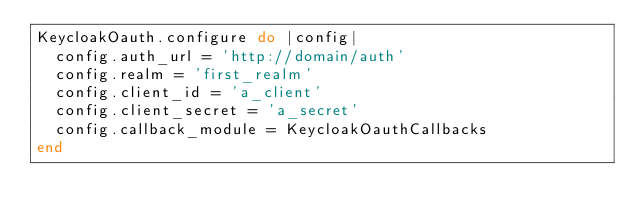<code> <loc_0><loc_0><loc_500><loc_500><_Ruby_>KeycloakOauth.configure do |config|
  config.auth_url = 'http://domain/auth'
  config.realm = 'first_realm'
  config.client_id = 'a_client'
  config.client_secret = 'a_secret'
  config.callback_module = KeycloakOauthCallbacks
end
</code> 